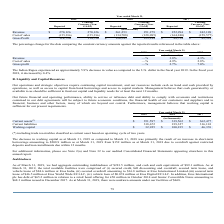According to Eros International Plc's financial document, What caused the decrease in working capital in 2019? primarily the result of an increase in short-term borrowings amounting to $208.9 million as at March 31, 2019 from $152 million as at March 31, 2018 due to overdraft against restricted deposits and loan installments due within 12 months.. The document states: "t March 31, 2019 as compared to March 31, 2018 was primarily the result of an increase in short-term borrowings amounting to $208.9 million as at Marc..." Also, What was the Working capital in 2019? According to the financial document, $32,925 (in thousands). The relevant text states: "Working capital $ 32,925 $ 100,235 $ 46,376..." Also, What years are included in the table? The document contains multiple relevant values: 2019, 2018, 2017. From the document: "2019 2018 2017 2019 2018 2017 2019 2018 2017..." Also, can you calculate: What is the increase / (decrease) in the current assets from 2018 to 2019? Based on the calculation: 351,597 - 339,562, the result is 12035 (in thousands). This is based on the information: "Current assets (*) $ 351,597 $ 339,562 $ 362,477 Current assets (*) $ 351,597 $ 339,562 $ 362,477..." The key data points involved are: 339,562, 351,597. Also, can you calculate: What is the average current liabilities from 2017-2019? To answer this question, I need to perform calculations using the financial data. The calculation is: (318,672 + 239,327 + 316,101) / 3, which equals 291366.67 (in thousands). This is based on the information: "Current liabilities 318,672 239,327 316,101 Current liabilities 318,672 239,327 316,101 Current liabilities 318,672 239,327 316,101..." The key data points involved are: 239,327, 316,101, 318,672. Also, can you calculate: What is the increase / (decrease) in the working capital from 2018 to 2019? Based on the calculation: 32,925 - 100,235, the result is -67310 (in thousands). This is based on the information: "Working capital $ 32,925 $ 100,235 $ 46,376 Working capital $ 32,925 $ 100,235 $ 46,376..." The key data points involved are: 100,235, 32,925. 